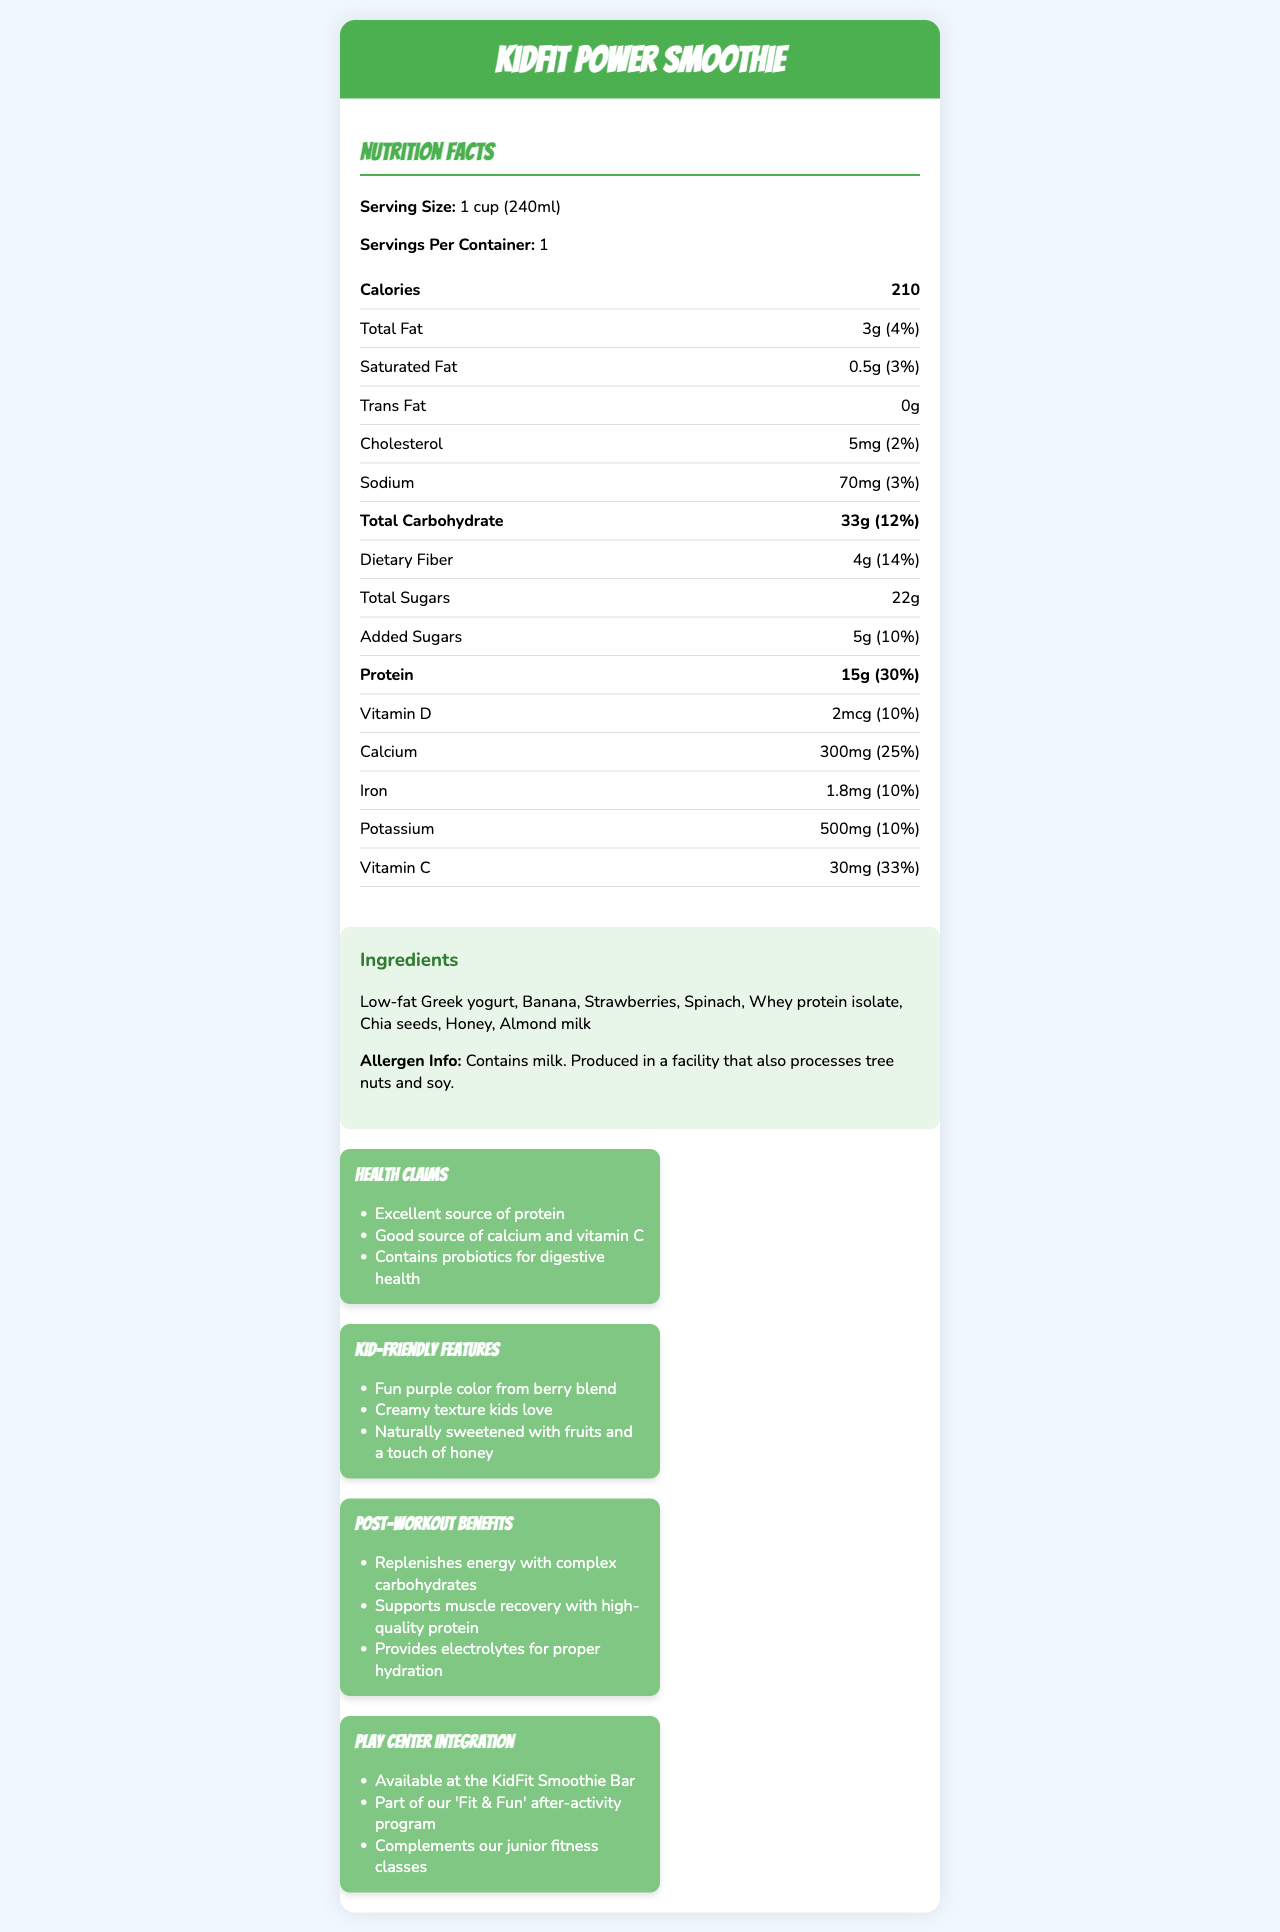what is the product name? The document title clearly states the product name as "KidFit Power Smoothie."
Answer: KidFit Power Smoothie what is the serving size? The serving size is explicitly mentioned as "1 cup (240ml)" in the nutrition facts section.
Answer: 1 cup (240ml) how many calories are in one serving? The document indicates that one serving contains 210 calories.
Answer: 210 what is the total amount of protein in one serving? The nutrition facts label specifies that there are 15 grams of protein per serving.
Answer: 15g how much sugar is added to the smoothie? The added sugars section lists 5 grams of added sugars.
Answer: 5g what is the percentage of daily value for dietary fiber? The document states that the daily value percentage for dietary fiber is 14%.
Answer: 14% which ingredient could cause an allergic reaction for kids with nut allergies? The allergen info section mentions that the product contains milk and is produced in a facility that also processes tree nuts and soy, indicating that almond milk is a potential allergen.
Answer: Almond milk how much calcium does the KidFit Power Smoothie contain? The calcium content is listed as 300mg in the nutrition facts.
Answer: 300mg what are the benefits of the KidFit Power Smoothie for post-workout recovery? A. Replenishes energy B. Supports muscle recovery C. Provides electrolytes D. All of the above The post-workout benefits section clearly states that the smoothie replenishes energy, supports muscle recovery, and provides electrolytes.
Answer: D. All of the above which health claim is NOT listed for the KidFit Power Smoothie? A. Contains probiotics for digestive health B. Supports heart health C. Excellent source of protein D. Good source of calcium and vitamin C The health claims section does not mention heart health; it mentions the other three options.
Answer: B. Supports heart health does the KidFit Power Smoothie contain any trans fat? The nutrition facts show that the trans fat content is 0g, indicating no trans fat.
Answer: No describe the main idea of the document The document highlights the nutritional benefits and kid-friendly features of the KidFit Power Smoothie, aiming to present it as a healthy option for children, particularly after physical activities at the play center.
Answer: The document provides a detailed overview of the KidFit Power Smoothie, including its nutritional content, ingredients, allergen information, health claims, kid-friendly features, post-workout benefits, and how it integrates with the play center's activities. It emphasizes the smoothie's suitability for kids as a healthy, protein-packed option for post-workout recovery. how is the KidFit Power Smoothie naturally sweetened? The kid-friendly features section mentions that the smoothie is naturally sweetened with fruits and a touch of honey.
Answer: With fruits and a touch of honey what is the color of the KidFit Power Smoothie? The kid-friendly features section states that the smoothie has a fun purple color from the berry blend.
Answer: Fun purple can the exact sources of the vitamins and minerals in the KidFit Power Smoothie be determined from the document? The document lists the vitamin and mineral content but does not specify the exact sources of these nutrients.
Answer: Cannot be determined 